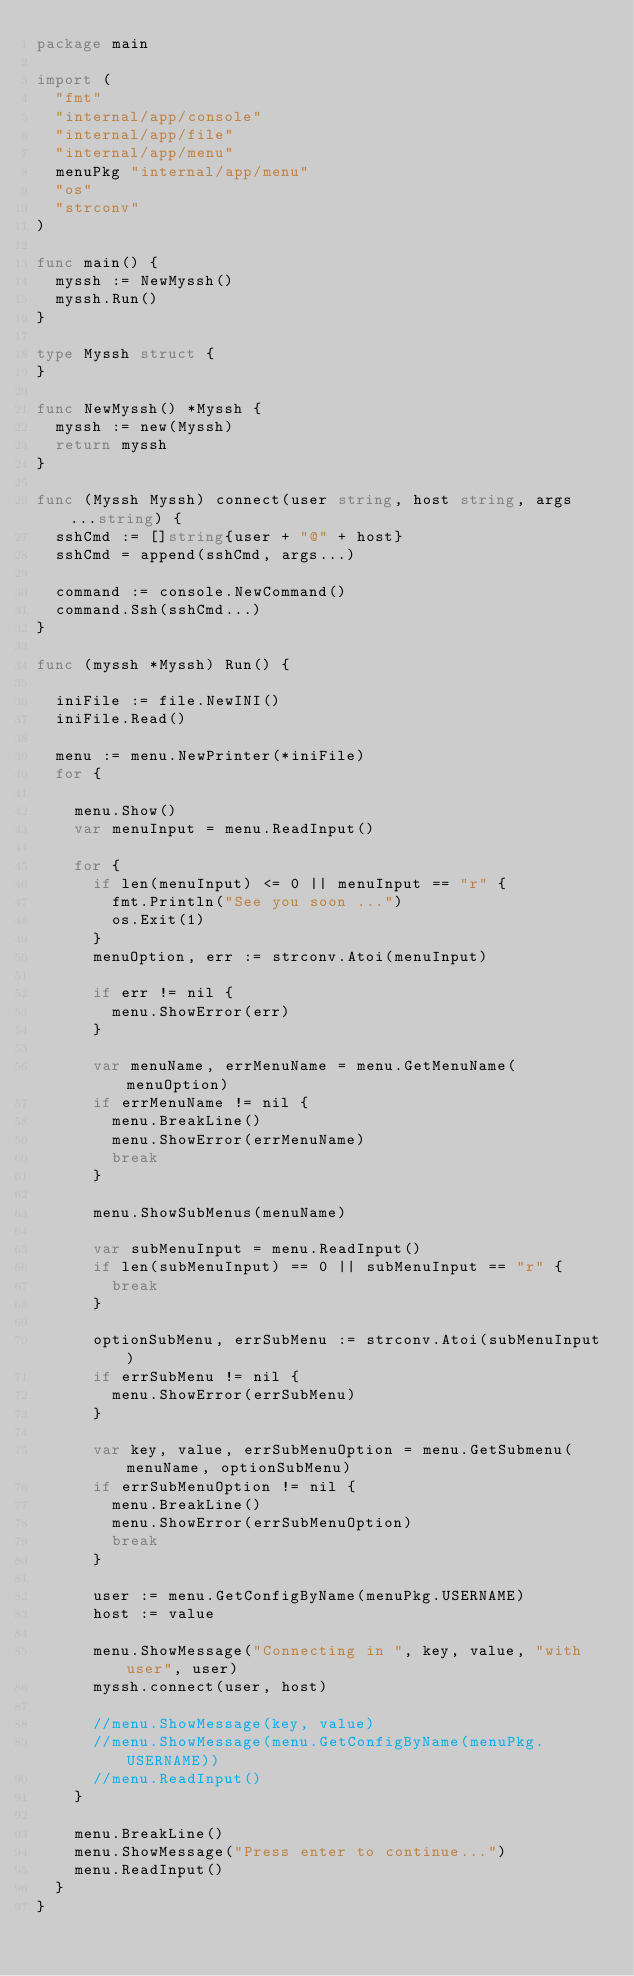Convert code to text. <code><loc_0><loc_0><loc_500><loc_500><_Go_>package main

import (
	"fmt"
	"internal/app/console"
	"internal/app/file"
	"internal/app/menu"
	menuPkg "internal/app/menu"
	"os"
	"strconv"
)

func main() {
	myssh := NewMyssh()
	myssh.Run()
}

type Myssh struct {
}

func NewMyssh() *Myssh {
	myssh := new(Myssh)
	return myssh
}

func (Myssh Myssh) connect(user string, host string, args ...string) {
	sshCmd := []string{user + "@" + host}
	sshCmd = append(sshCmd, args...)

	command := console.NewCommand()
	command.Ssh(sshCmd...)
}

func (myssh *Myssh) Run() {

	iniFile := file.NewINI()
	iniFile.Read()

	menu := menu.NewPrinter(*iniFile)
	for {

		menu.Show()
		var menuInput = menu.ReadInput()

		for {
			if len(menuInput) <= 0 || menuInput == "r" {
				fmt.Println("See you soon ...")
				os.Exit(1)
			}
			menuOption, err := strconv.Atoi(menuInput)

			if err != nil {
				menu.ShowError(err)
			}

			var menuName, errMenuName = menu.GetMenuName(menuOption)
			if errMenuName != nil {
				menu.BreakLine()
				menu.ShowError(errMenuName)
				break
			}

			menu.ShowSubMenus(menuName)

			var subMenuInput = menu.ReadInput()
			if len(subMenuInput) == 0 || subMenuInput == "r" {
				break
			}

			optionSubMenu, errSubMenu := strconv.Atoi(subMenuInput)
			if errSubMenu != nil {
				menu.ShowError(errSubMenu)
			}

			var key, value, errSubMenuOption = menu.GetSubmenu(menuName, optionSubMenu)
			if errSubMenuOption != nil {
				menu.BreakLine()
				menu.ShowError(errSubMenuOption)
				break
			}

			user := menu.GetConfigByName(menuPkg.USERNAME)
			host := value

			menu.ShowMessage("Connecting in ", key, value, "with user", user)
			myssh.connect(user, host)

			//menu.ShowMessage(key, value)
			//menu.ShowMessage(menu.GetConfigByName(menuPkg.USERNAME))
			//menu.ReadInput()
		}

		menu.BreakLine()
		menu.ShowMessage("Press enter to continue...")
		menu.ReadInput()
	}
}
</code> 